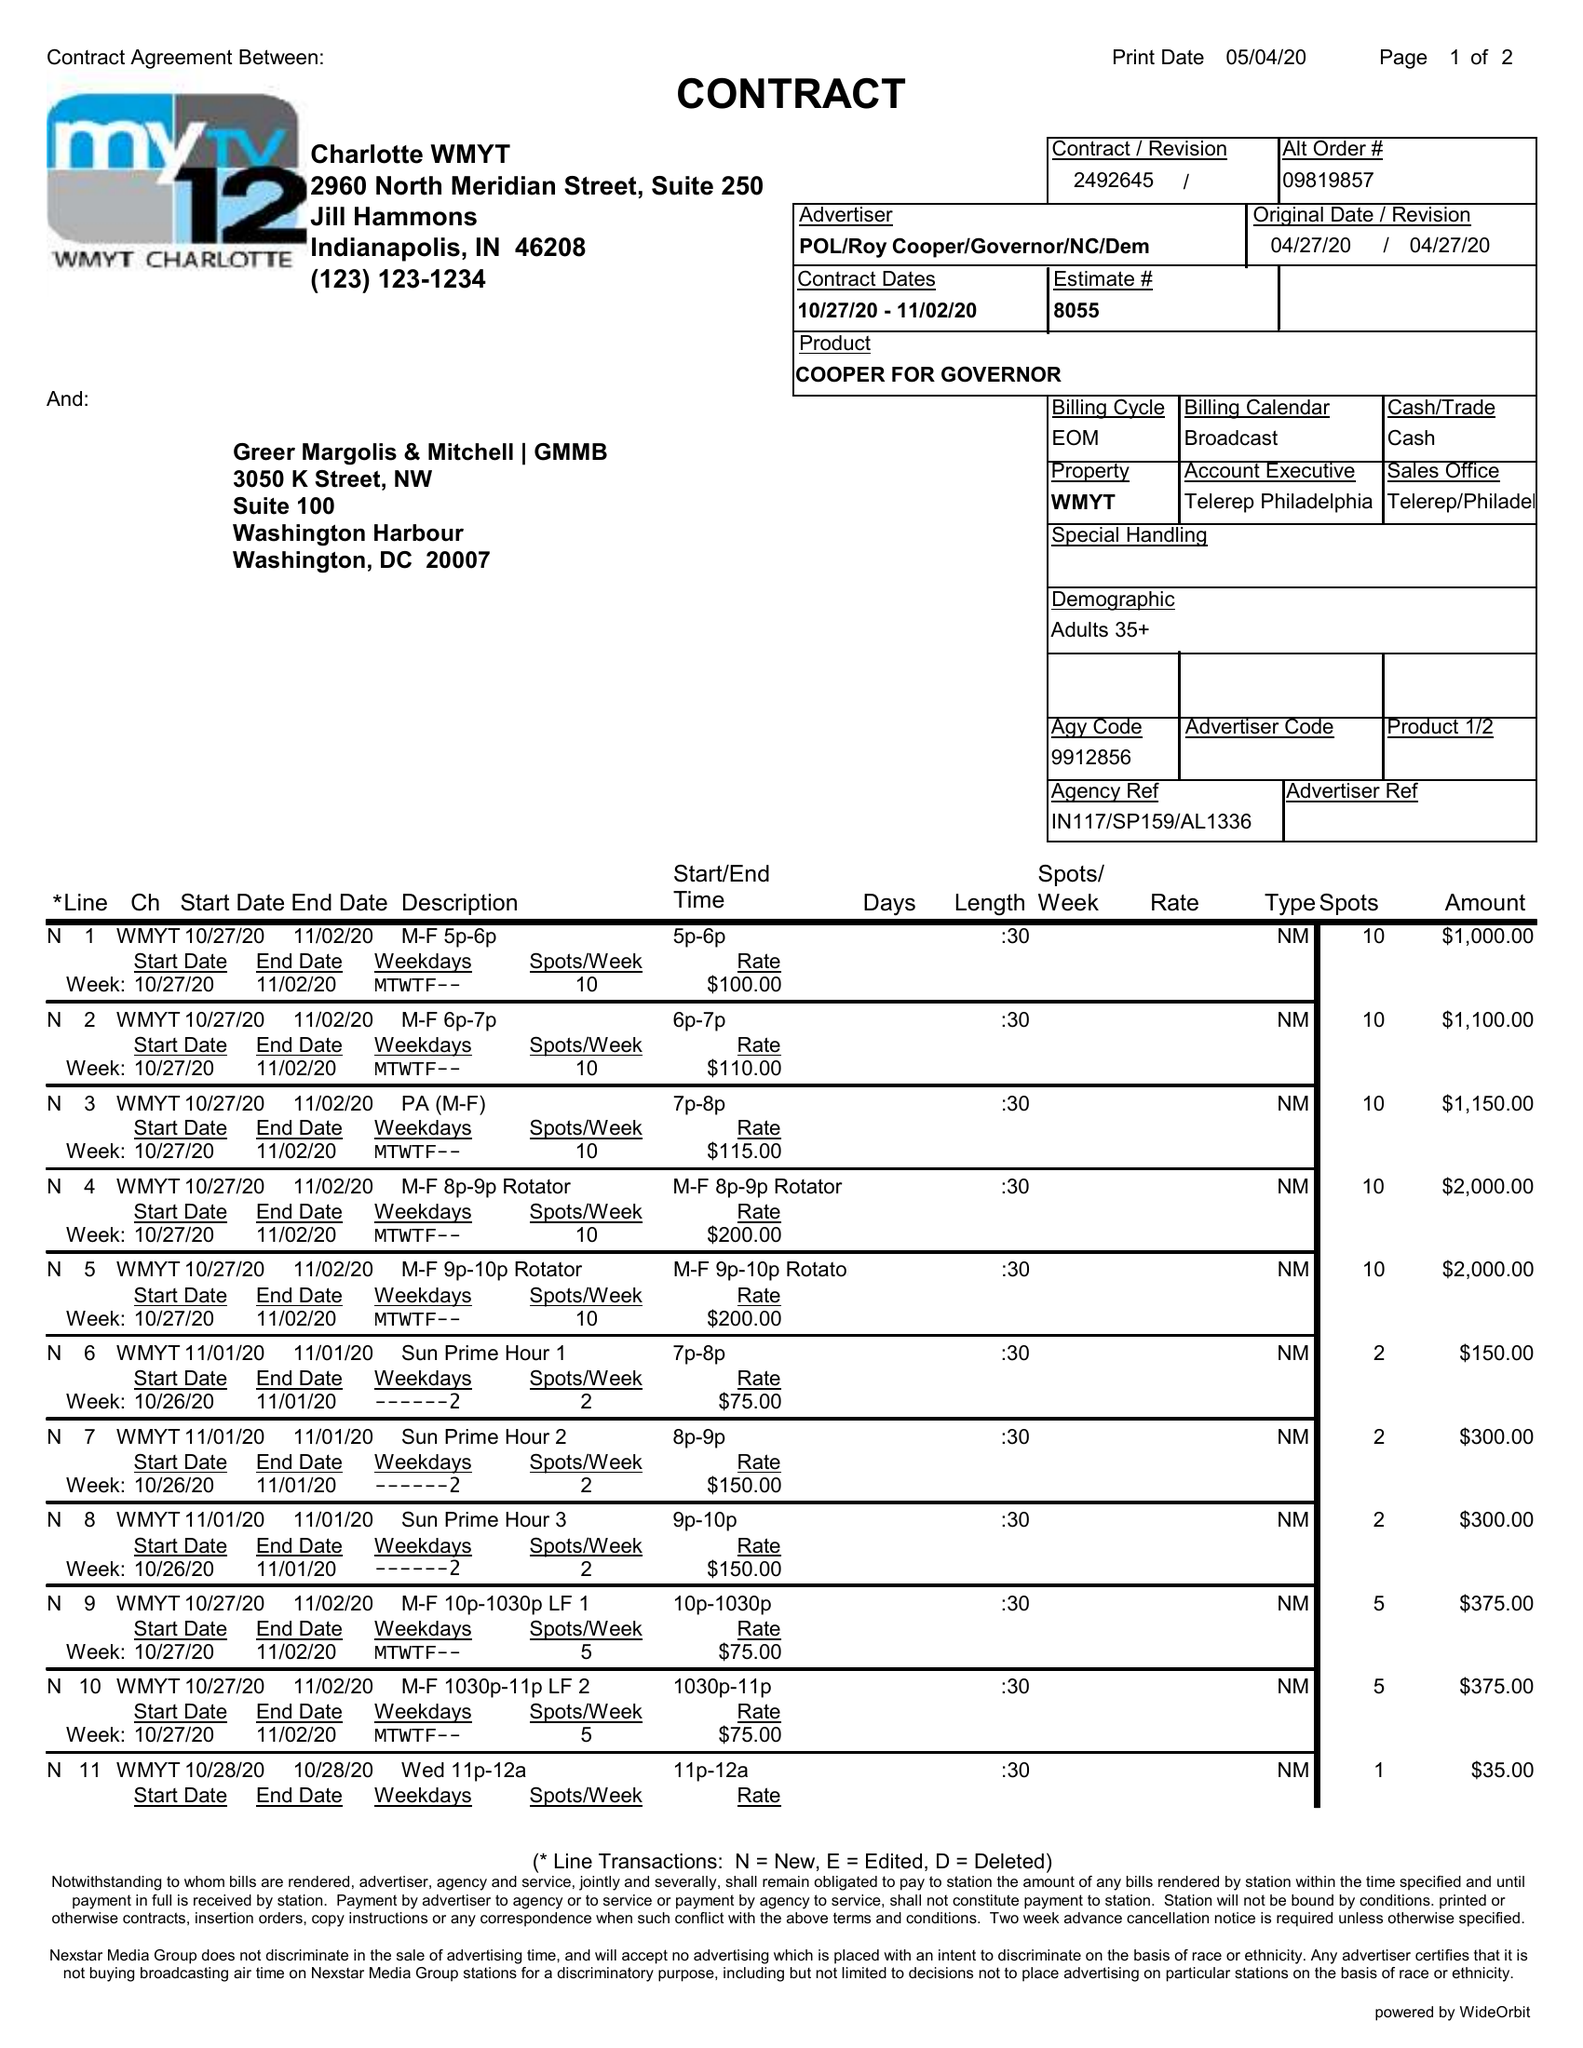What is the value for the flight_to?
Answer the question using a single word or phrase. 11/02/20 